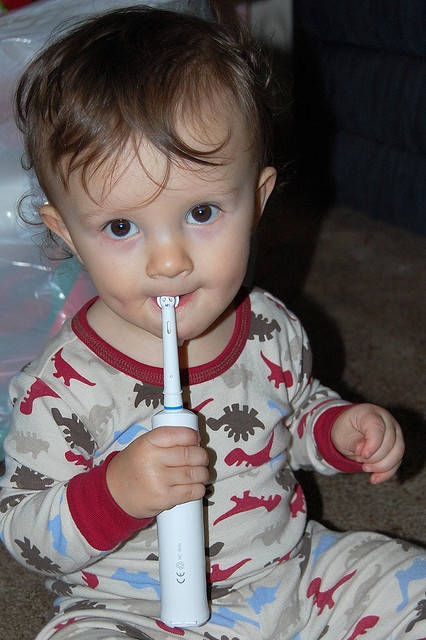Describe the objects in this image and their specific colors. I can see people in maroon, darkgray, black, and gray tones and toothbrush in maroon, lightblue, and darkgray tones in this image. 